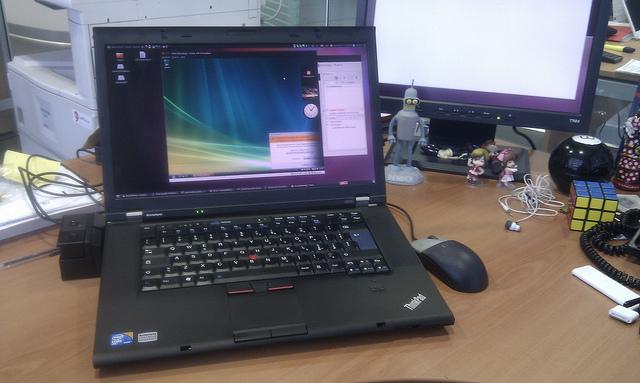How many keyboards do you see?
Concise answer only. 1. How many keys are on the laptop keyboard?
Quick response, please. 50. Are these computer connected through a network?
Short answer required. Yes. What color is the marker cap?
Be succinct. Black. Where is the Rubik's cube?
Write a very short answer. Right. Is the mouse wireless?
Be succinct. No. Who is the cartoon character on the immediate right of the laptop?
Short answer required. Bender. What toy is next to the monitor?
Answer briefly. Rubik's cube. What brand is this computer?
Quick response, please. Dell. What color is the small circle on the spacebar of the keyboard?
Write a very short answer. Red. What does the person use the laptop for?
Be succinct. Work. Are the mouses wireless?
Give a very brief answer. No. Where are the action figures located?
Answer briefly. Desk. How many remotes are on the table?
Keep it brief. 0. Is the purple border a soft lilac hue?
Give a very brief answer. Yes. How many keyboards are visible?
Short answer required. 1. What color is the laptop?
Quick response, please. Black. Is the laptop computer turned on?
Keep it brief. Yes. What brand computer is this?
Answer briefly. Lenovo. What are the computers on top of?
Write a very short answer. Desk. Is the keyboard curved?
Concise answer only. No. Behind the computer on the right is a statue of what cartoon character?
Answer briefly. Robot. 